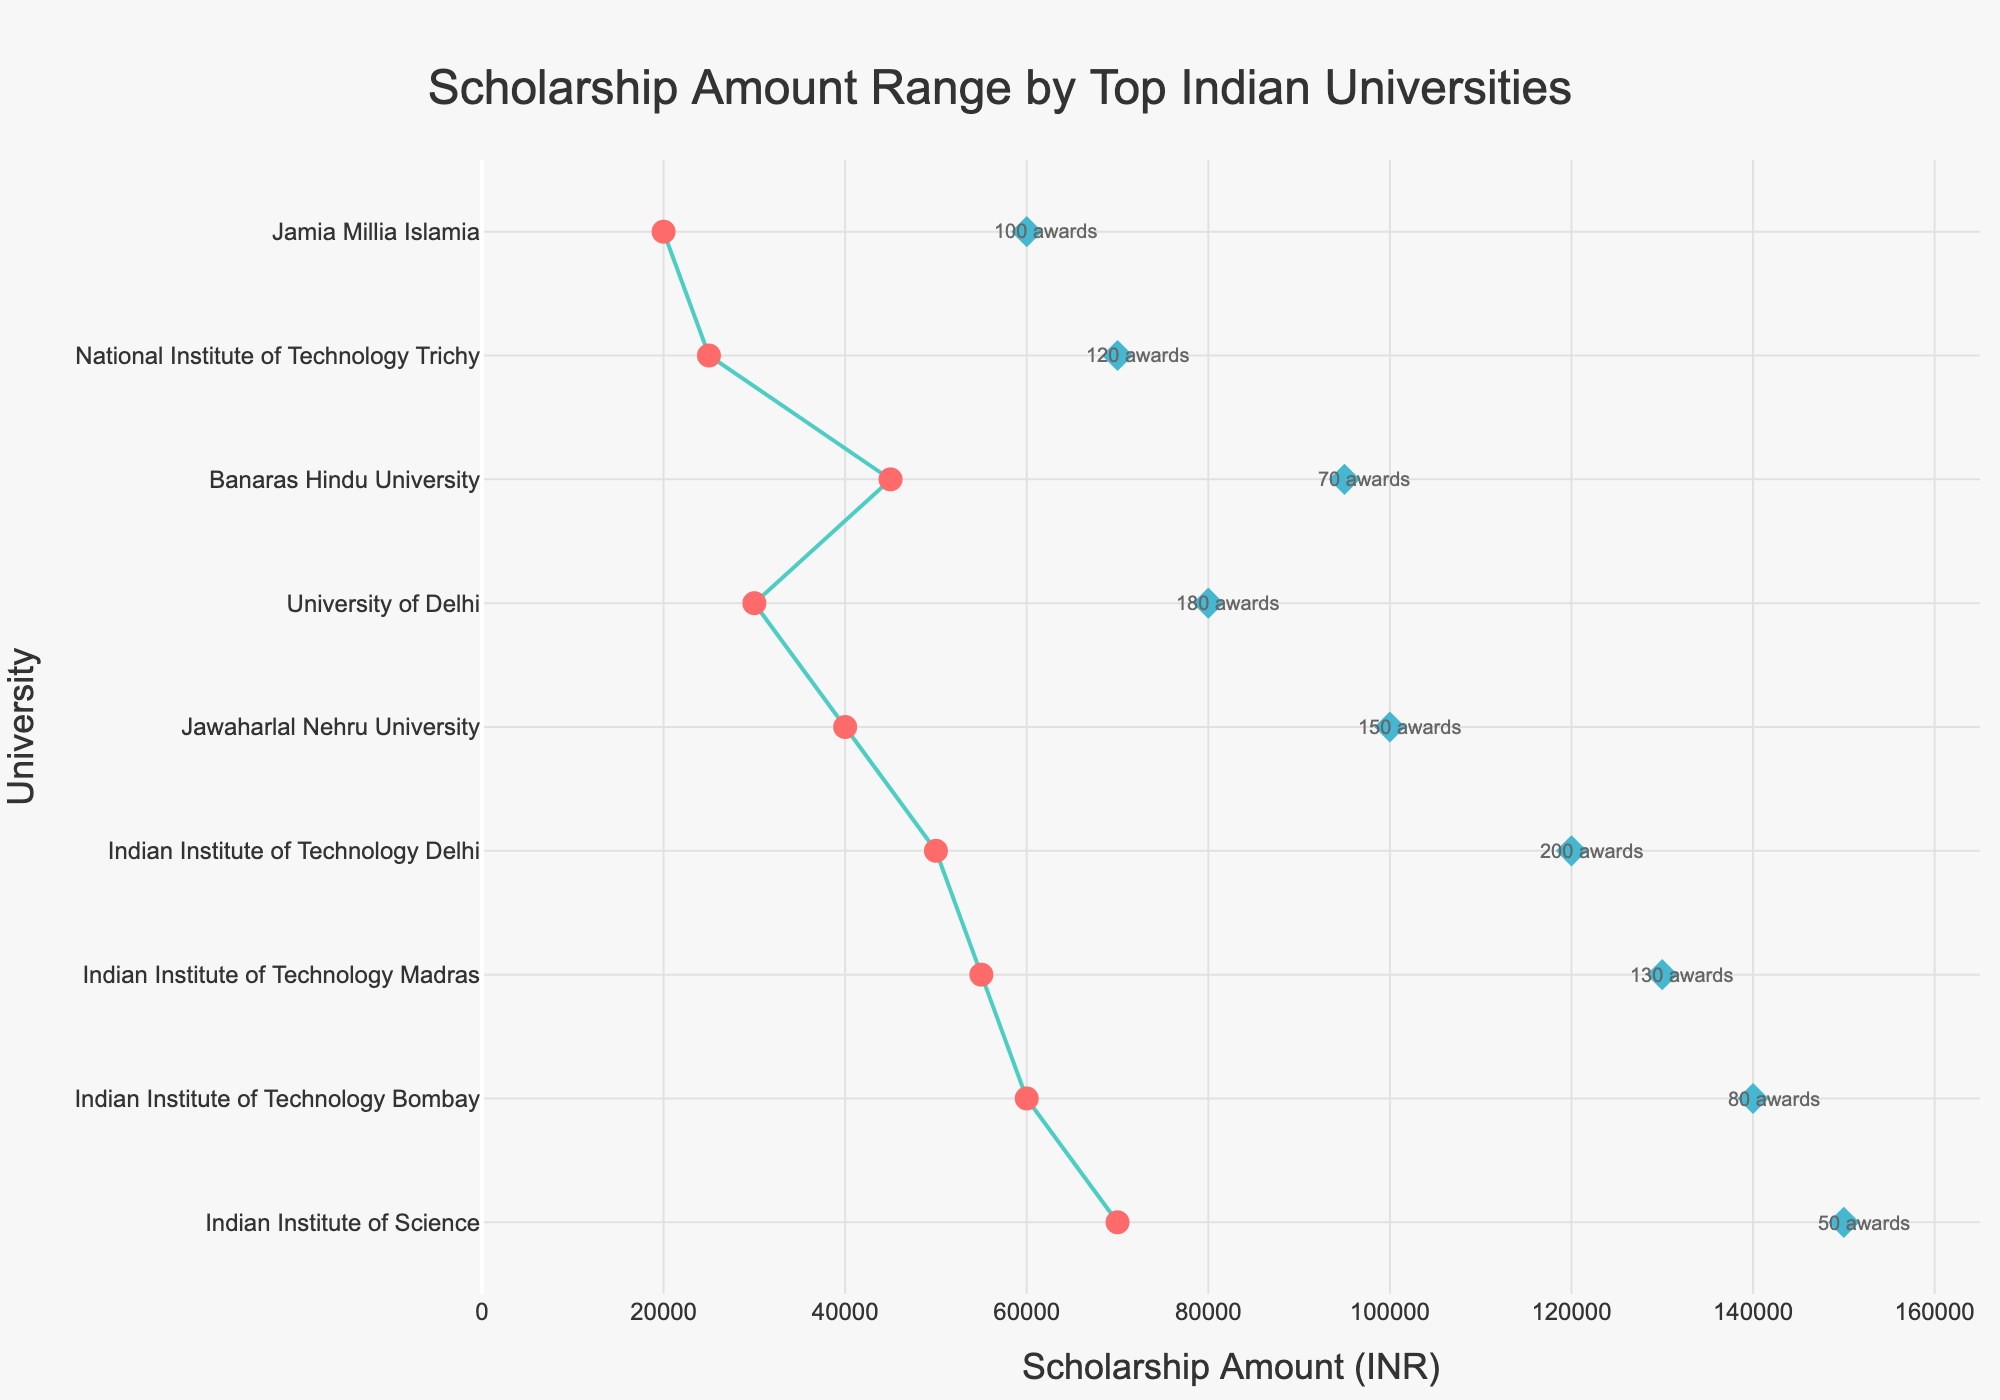Is the scholarship with the highest maximum amount awarded by IIT Delhi? Look for the university with the highest maximum scholarship amount. Indian Institute of Science has the highest maximum scholarship amount of ₹150,000, which is more than IIT Delhi's ₹120,000.
Answer: No Which university has the most number of awards? Check the annotations near the diamonds for the number of awards. IIT Delhi offers the most awards, with a count of 200.
Answer: IIT Delhi What is the range of the Narotam Sekhsaria Scholarship at IIT Bombay? Subtract the minimum amount from the maximum amount for Narotam Sekhsaria Scholarship. Max is ₹140,000 and Min is ₹60,000, so the range is ₹140,000 - ₹60,000 = ₹80,000.
Answer: ₹80,000 Which university offers the smallest minimum scholarship amount? Find the smallest red circle on the x-axis. Jamia Millia Islamia offers the smallest minimum scholarship amount of ₹20,000.
Answer: Jamia Millia Islamia How many awards are given by Banaras Hindu University? Look for the annotation near Banaras Hindu University, which states the number of awards. Banaras Hindu University grants 70 awards.
Answer: 70 Which university has the narrowest range of scholarship amounts? Find the university with the smallest difference between the max and min amounts. NIT Trichy has the smallest range of ₹45,000 (₹70,000 - ₹25,000 is the smallest range).
Answer: NIT Trichy What is the difference between the maximum scholarship amounts of IIT Madras and JNU? Subtract the maximum amount of JNU from IIT Madras. Max for IIT Madras is ₹130,000, and for JNU is ₹100,000, so it's ₹130,000 - ₹100,000 = ₹30,000.
Answer: ₹30,000 Does Jamia Millia Islamia provide scholarships of up to ₹60,000? Check the maximum amount marked by the diamond for Jamia Millia Islamia. It shows ₹60,000 as the maximum amount.
Answer: Yes Compare the scholarship ranges of IIT Delhi and University of Delhi. Which has a larger range? Calculate the range for both: IIT Delhi ranges from ₹50,000 to ₹120,000, so its range is ₹70,000. University of Delhi ranges from ₹30,000 to ₹80,000, so its range is ₹50,000. IIT Delhi has a larger range.
Answer: IIT Delhi 